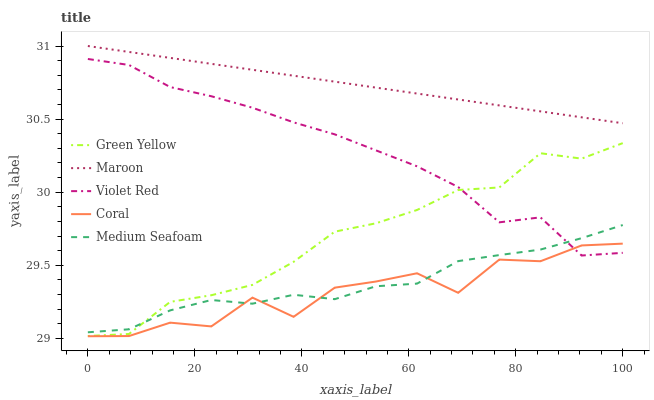Does Coral have the minimum area under the curve?
Answer yes or no. Yes. Does Maroon have the maximum area under the curve?
Answer yes or no. Yes. Does Green Yellow have the minimum area under the curve?
Answer yes or no. No. Does Green Yellow have the maximum area under the curve?
Answer yes or no. No. Is Maroon the smoothest?
Answer yes or no. Yes. Is Coral the roughest?
Answer yes or no. Yes. Is Green Yellow the smoothest?
Answer yes or no. No. Is Green Yellow the roughest?
Answer yes or no. No. Does Coral have the lowest value?
Answer yes or no. Yes. Does Green Yellow have the lowest value?
Answer yes or no. No. Does Maroon have the highest value?
Answer yes or no. Yes. Does Green Yellow have the highest value?
Answer yes or no. No. Is Coral less than Maroon?
Answer yes or no. Yes. Is Maroon greater than Coral?
Answer yes or no. Yes. Does Medium Seafoam intersect Coral?
Answer yes or no. Yes. Is Medium Seafoam less than Coral?
Answer yes or no. No. Is Medium Seafoam greater than Coral?
Answer yes or no. No. Does Coral intersect Maroon?
Answer yes or no. No. 